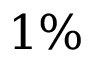Convert formula to latex. <formula><loc_0><loc_0><loc_500><loc_500>1 \%</formula> 